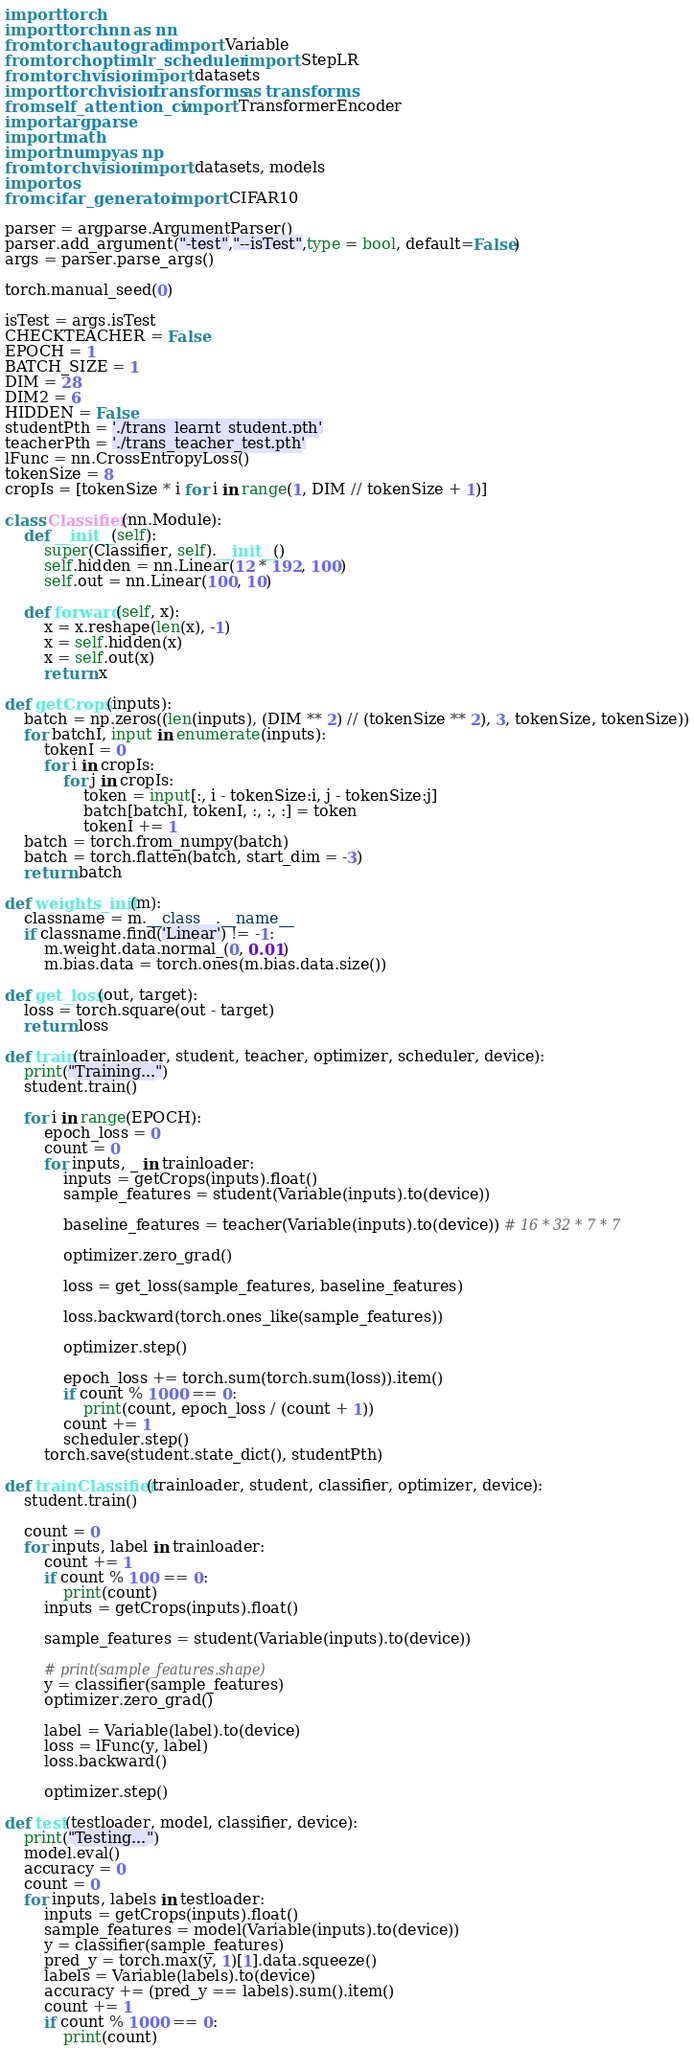Convert code to text. <code><loc_0><loc_0><loc_500><loc_500><_Python_>import torch
import torch.nn as nn
from torch.autograd import Variable
from torch.optim.lr_scheduler import StepLR
from torchvision import datasets
import torchvision.transforms as transforms
from self_attention_cv import TransformerEncoder
import argparse
import math
import numpy as np
from torchvision import datasets, models
import os
from cifar_generator import CIFAR10

parser = argparse.ArgumentParser()
parser.add_argument("-test","--isTest",type = bool, default=False)
args = parser.parse_args()

torch.manual_seed(0)

isTest = args.isTest
CHECKTEACHER = False
EPOCH = 1
BATCH_SIZE = 1
DIM = 28
DIM2 = 6
HIDDEN = False
studentPth = './trans_learnt_student.pth'
teacherPth = './trans_teacher_test.pth'
lFunc = nn.CrossEntropyLoss()
tokenSize = 8
cropIs = [tokenSize * i for i in range(1, DIM // tokenSize + 1)]

class Classifier(nn.Module):
    def __init__(self):
        super(Classifier, self).__init__()
        self.hidden = nn.Linear(12 * 192, 100)
        self.out = nn.Linear(100, 10)

    def forward(self, x):
        x = x.reshape(len(x), -1)
        x = self.hidden(x)
        x = self.out(x)
        return x

def getCrops(inputs):
    batch = np.zeros((len(inputs), (DIM ** 2) // (tokenSize ** 2), 3, tokenSize, tokenSize))
    for batchI, input in enumerate(inputs):
        tokenI = 0
        for i in cropIs:
            for j in cropIs:
                token = input[:, i - tokenSize:i, j - tokenSize:j]
                batch[batchI, tokenI, :, :, :] = token
                tokenI += 1
    batch = torch.from_numpy(batch)
    batch = torch.flatten(batch, start_dim = -3)
    return batch

def weights_init(m):
    classname = m.__class__.__name__
    if classname.find('Linear') != -1:
        m.weight.data.normal_(0, 0.01)
        m.bias.data = torch.ones(m.bias.data.size())

def get_loss(out, target):
    loss = torch.square(out - target)
    return loss

def train(trainloader, student, teacher, optimizer, scheduler, device):
    print("Training...")
    student.train()

    for i in range(EPOCH):
        epoch_loss = 0
        count = 0
        for inputs, _ in trainloader:
            inputs = getCrops(inputs).float()
            sample_features = student(Variable(inputs).to(device))

            baseline_features = teacher(Variable(inputs).to(device)) # 16 * 32 * 7 * 7

            optimizer.zero_grad()

            loss = get_loss(sample_features, baseline_features)

            loss.backward(torch.ones_like(sample_features))

            optimizer.step()

            epoch_loss += torch.sum(torch.sum(loss)).item()
            if count % 1000 == 0:
                print(count, epoch_loss / (count + 1))
            count += 1
            scheduler.step()
        torch.save(student.state_dict(), studentPth)

def trainClassifier(trainloader, student, classifier, optimizer, device):
    student.train()

    count = 0
    for inputs, label in trainloader:
        count += 1
        if count % 100 == 0:
            print(count)
        inputs = getCrops(inputs).float()
        
        sample_features = student(Variable(inputs).to(device))

        # print(sample_features.shape)
        y = classifier(sample_features)
        optimizer.zero_grad()

        label = Variable(label).to(device)
        loss = lFunc(y, label)
        loss.backward()

        optimizer.step()

def test(testloader, model, classifier, device):
    print("Testing...")
    model.eval()
    accuracy = 0
    count = 0
    for inputs, labels in testloader:
        inputs = getCrops(inputs).float()
        sample_features = model(Variable(inputs).to(device))
        y = classifier(sample_features)
        pred_y = torch.max(y, 1)[1].data.squeeze()
        labels = Variable(labels).to(device)
        accuracy += (pred_y == labels).sum().item()
        count += 1
        if count % 1000 == 0:
            print(count)</code> 